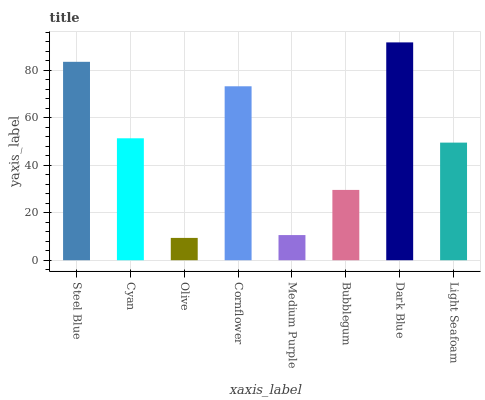Is Olive the minimum?
Answer yes or no. Yes. Is Dark Blue the maximum?
Answer yes or no. Yes. Is Cyan the minimum?
Answer yes or no. No. Is Cyan the maximum?
Answer yes or no. No. Is Steel Blue greater than Cyan?
Answer yes or no. Yes. Is Cyan less than Steel Blue?
Answer yes or no. Yes. Is Cyan greater than Steel Blue?
Answer yes or no. No. Is Steel Blue less than Cyan?
Answer yes or no. No. Is Cyan the high median?
Answer yes or no. Yes. Is Light Seafoam the low median?
Answer yes or no. Yes. Is Olive the high median?
Answer yes or no. No. Is Cornflower the low median?
Answer yes or no. No. 